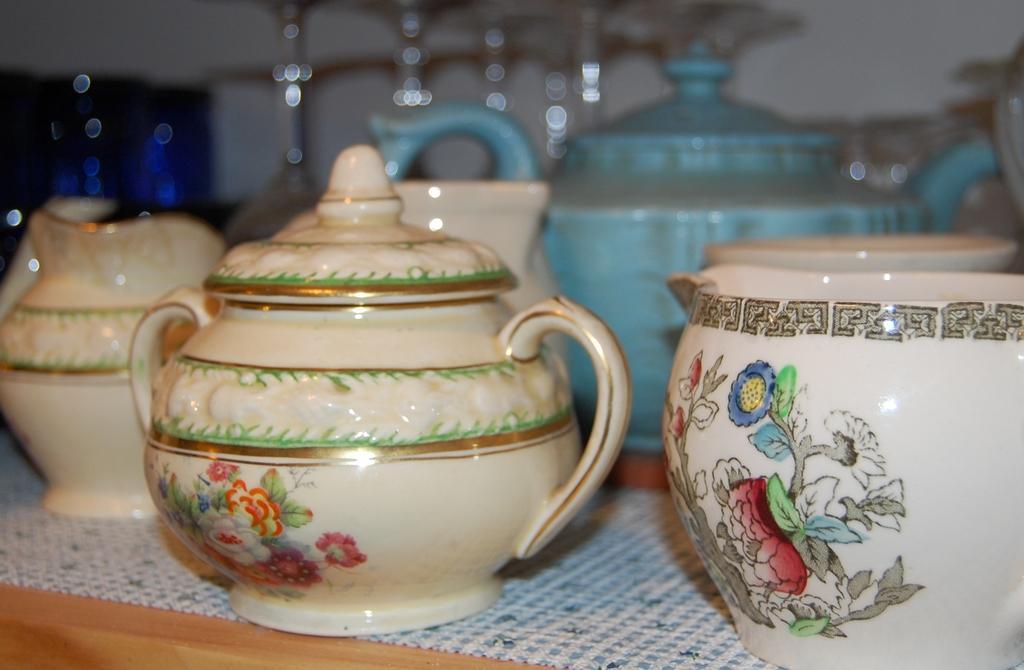Can you describe this image briefly? In this image we can see one table, some objects are on the surface, a white wall and some objects are on the surface. 